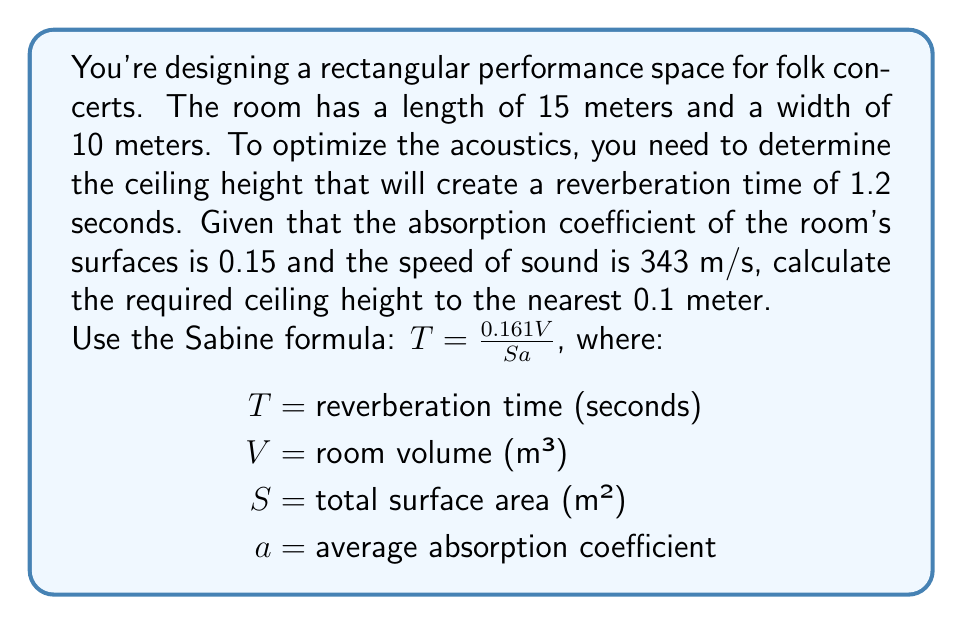Can you solve this math problem? Let's approach this step-by-step:

1) We know the following:
   - Length (L) = 15 m
   - Width (W) = 10 m
   - Height (H) = unknown
   - Reverberation time (T) = 1.2 s
   - Absorption coefficient (a) = 0.15
   - Speed of sound = 343 m/s (not directly used in calculation)

2) We'll use the Sabine formula: $T = \frac{0.161V}{Sa}$

3) Volume (V) = L × W × H = 15 × 10 × H = 150H m³

4) Surface area (S) = 2(LW + LH + WH) = 2(150 + 15H + 10H) = 300 + 50H m²

5) Substituting into the Sabine formula:
   $$1.2 = \frac{0.161(150H)}{(300 + 50H)(0.15)}$$

6) Simplifying:
   $$1.2 = \frac{24.15H}{45 + 7.5H}$$

7) Cross-multiplying:
   $$(45 + 7.5H)(1.2) = 24.15H$$
   $$54 + 9H = 24.15H$$

8) Solving for H:
   $$54 = 15.15H$$
   $$H = \frac{54}{15.15} \approx 3.56$$

9) Rounding to the nearest 0.1 meter:
   H ≈ 3.6 meters
Answer: 3.6 meters 